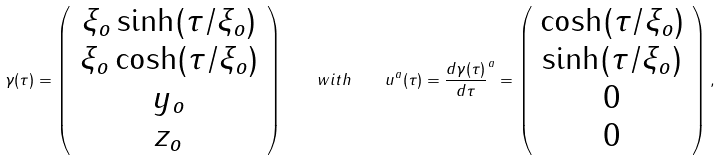Convert formula to latex. <formula><loc_0><loc_0><loc_500><loc_500>\gamma ( \tau ) = \left ( \begin{array} { c } \xi _ { o } \sinh ( \tau / \xi _ { o } ) \\ \xi _ { o } \cosh ( \tau / \xi _ { o } ) \\ y _ { o } \\ z _ { o } \end{array} \right ) \quad w i t h \quad u ^ { a } ( \tau ) = \frac { d \gamma ( \tau ) } { d \tau } ^ { a } = \left ( \begin{array} { c } \cosh ( \tau / \xi _ { o } ) \\ \sinh ( \tau / \xi _ { o } ) \\ 0 \\ 0 \end{array} \right ) ,</formula> 